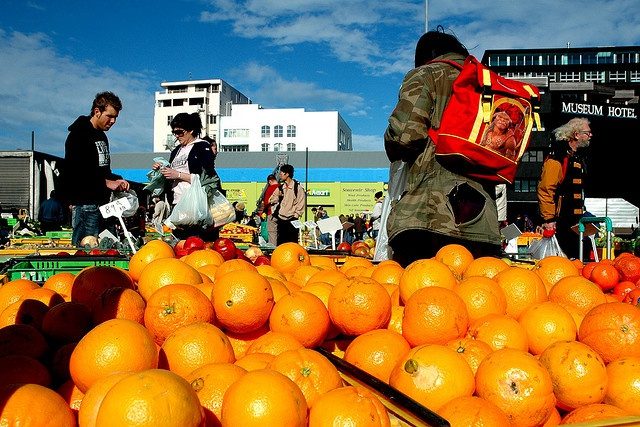Describe the objects in this image and their specific colors. I can see orange in blue, orange, red, black, and maroon tones, orange in blue, orange, red, and gold tones, people in blue, black, darkgreen, and gray tones, backpack in blue, red, black, brown, and maroon tones, and people in blue, black, maroon, gray, and teal tones in this image. 